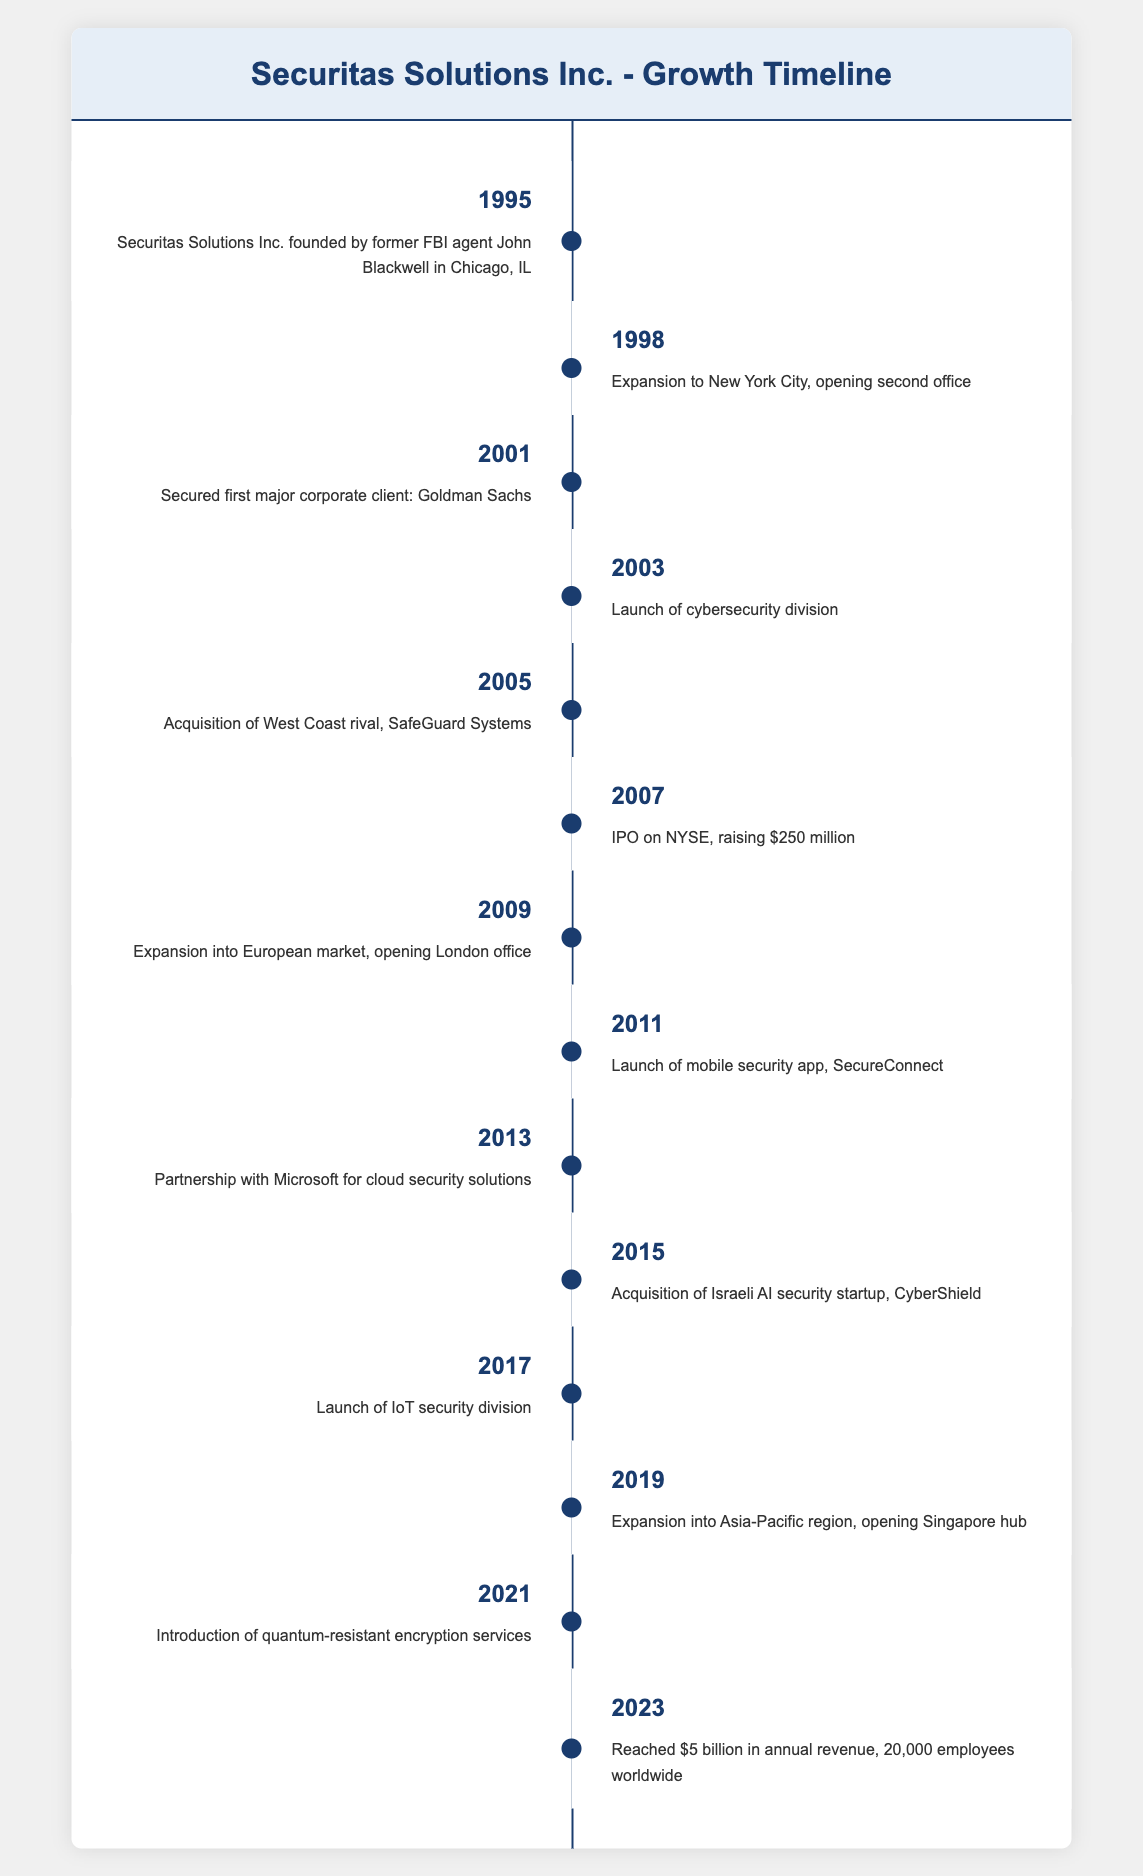What year was Securitas Solutions Inc. founded? The table indicates the founding year of Securitas Solutions Inc. as 1995. This is the first entry in the timeline data.
Answer: 1995 What major milestone occurred in 2007? According to the timeline, the major milestone in 2007 was the company's IPO on the NYSE, which raised $250 million. This is highlighted in the specific event for that year.
Answer: IPO on NYSE, raising $250 million Did the company launch a mobile security app? Yes, the timeline shows that a mobile security app called SecureConnect was launched in 2011, as indicated in the corresponding event entry.
Answer: Yes What is the total number of major milestones listed from 1995 to 2023? There are 14 milestones listed in the timeline, as each event from 1995 to 2023 represents a significant point in the company's history. Counting each entry gives us 14 events.
Answer: 14 In which year did Securitas Solutions Inc. expand into the European market? The expansion into the European market occurred in 2009, as noted in the event description for that year in the table. This event indicates the opening of the London office.
Answer: 2009 Which two years included significant acquisitions? The years 2005 and 2015 both included significant acquisitions noted in their respective events. In 2005, the company acquired SafeGuard Systems, and in 2015, it acquired CyberShield. Identifying these two events confirms the answer.
Answer: 2005 and 2015 What was Securitas Solutions Inc.'s annual revenue in 2023? The table states that by 2023, the company reached an annual revenue of $5 billion. This is a clear point outlined in the last event of the timeline.
Answer: $5 billion Which year marks the launch of the IoT security division? The timeline indicates that the IoT security division was launched in 2017, making it a notable event in that year as listed in the table.
Answer: 2017 How many years are there between the founding and the first major corporate client acquisition? The company was founded in 1995 and secured its first major corporate client, Goldman Sachs, in 2001. The difference between 2001 and 1995 is 6 years, calculated by simple subtraction of the two years.
Answer: 6 years 